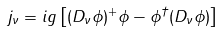Convert formula to latex. <formula><loc_0><loc_0><loc_500><loc_500>j _ { \nu } = i g \left [ ( D _ { \nu } \phi ) ^ { + } \phi - \phi ^ { \dagger } ( D _ { \nu } \phi ) \right ]</formula> 